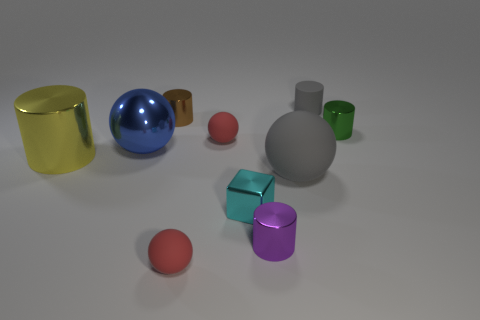Subtract all blue balls. How many balls are left? 3 Subtract 0 brown spheres. How many objects are left? 10 Subtract all cubes. How many objects are left? 9 Subtract 5 cylinders. How many cylinders are left? 0 Subtract all cyan cylinders. Subtract all red blocks. How many cylinders are left? 5 Subtract all green cubes. How many red cylinders are left? 0 Subtract all red spheres. Subtract all matte balls. How many objects are left? 5 Add 8 tiny purple metallic cylinders. How many tiny purple metallic cylinders are left? 9 Add 9 big purple matte balls. How many big purple matte balls exist? 9 Subtract all blue spheres. How many spheres are left? 3 